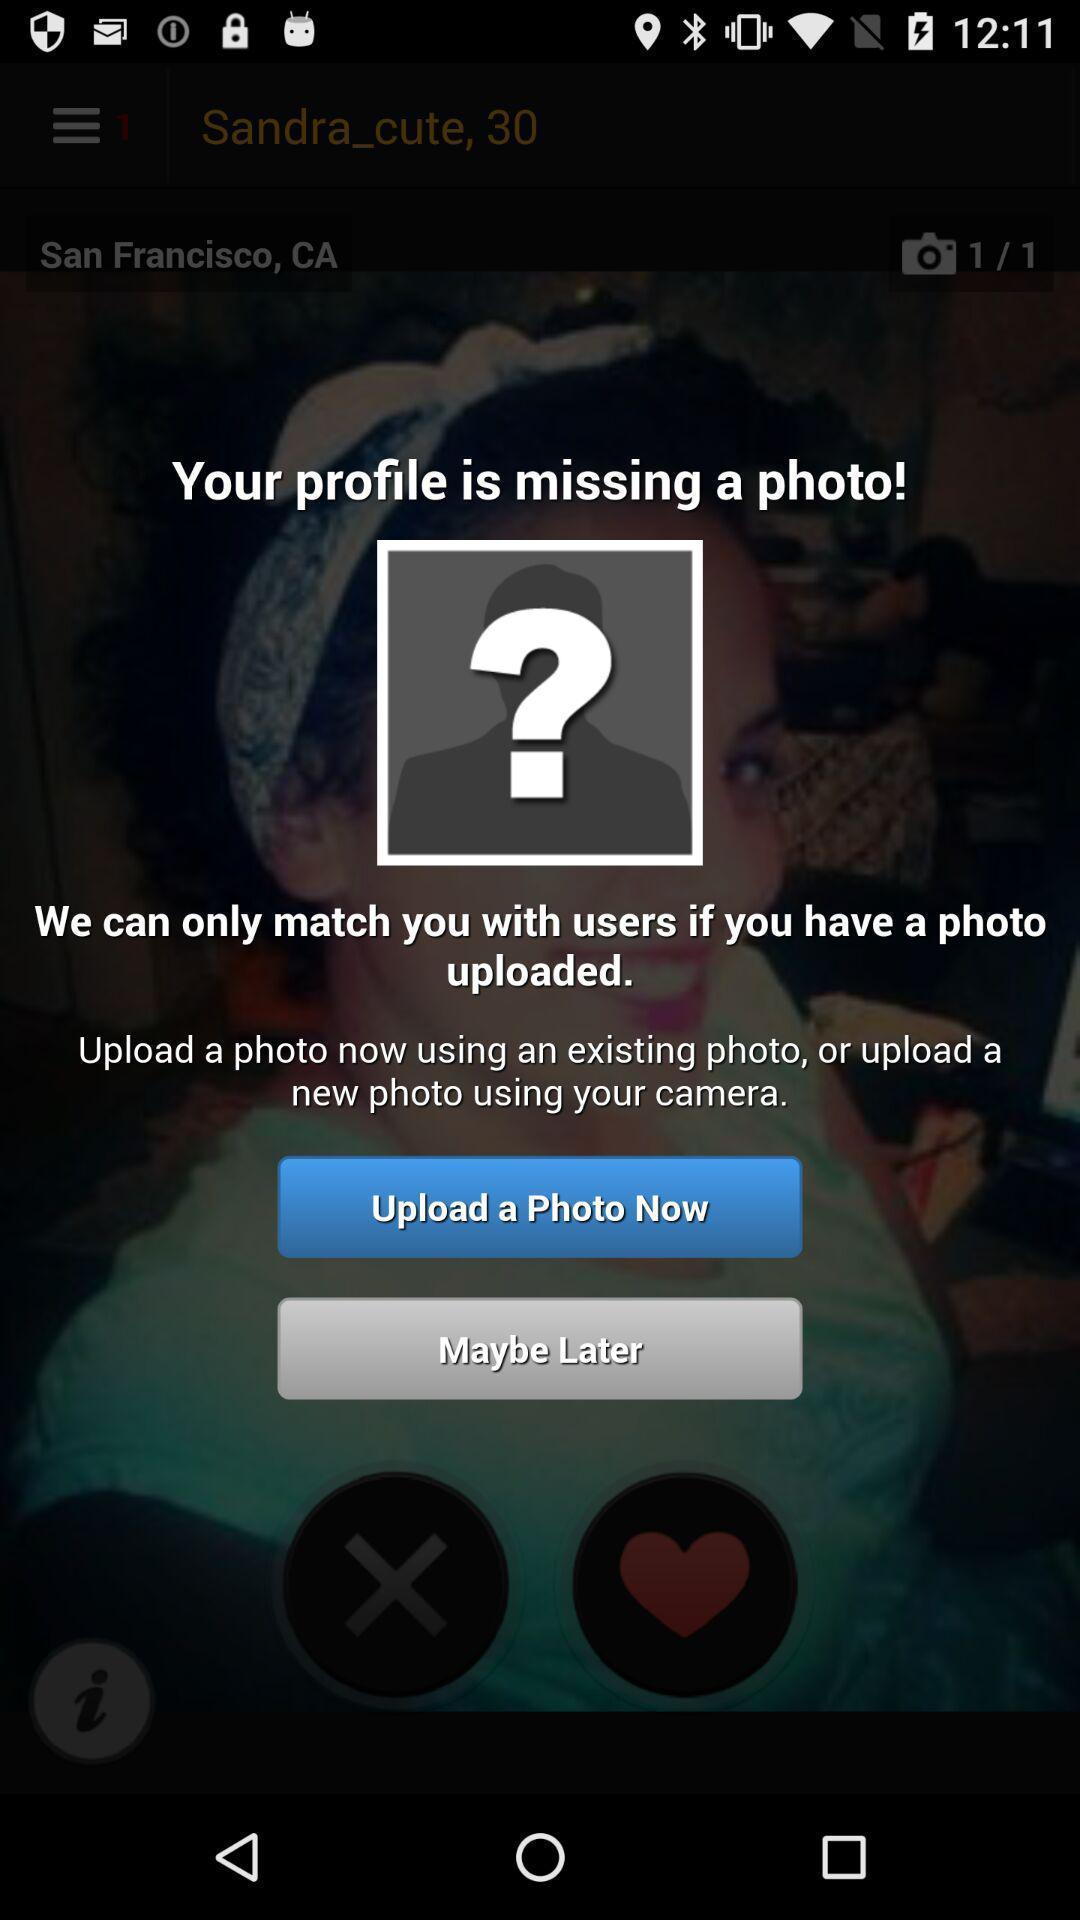Provide a detailed account of this screenshot. Pop-up screen with option to upload a photo. 